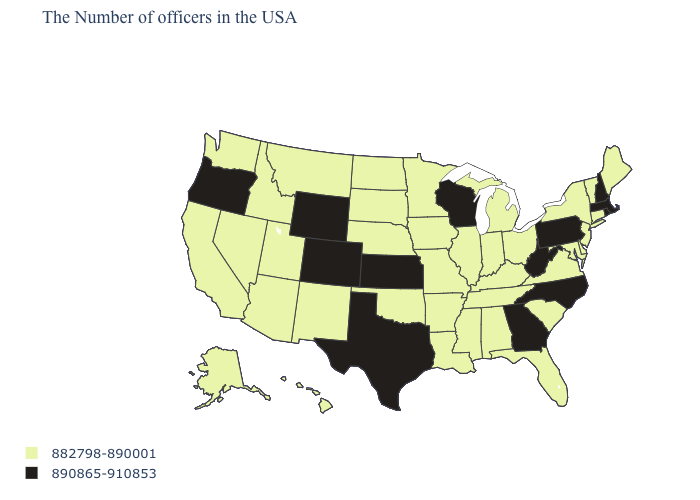Name the states that have a value in the range 890865-910853?
Answer briefly. Massachusetts, Rhode Island, New Hampshire, Pennsylvania, North Carolina, West Virginia, Georgia, Wisconsin, Kansas, Texas, Wyoming, Colorado, Oregon. What is the highest value in the USA?
Be succinct. 890865-910853. Does the map have missing data?
Write a very short answer. No. Does the map have missing data?
Answer briefly. No. What is the value of New Hampshire?
Short answer required. 890865-910853. Which states hav the highest value in the South?
Quick response, please. North Carolina, West Virginia, Georgia, Texas. What is the lowest value in the USA?
Quick response, please. 882798-890001. Which states have the highest value in the USA?
Give a very brief answer. Massachusetts, Rhode Island, New Hampshire, Pennsylvania, North Carolina, West Virginia, Georgia, Wisconsin, Kansas, Texas, Wyoming, Colorado, Oregon. Does Colorado have a higher value than Maine?
Be succinct. Yes. What is the value of Indiana?
Concise answer only. 882798-890001. Does the first symbol in the legend represent the smallest category?
Give a very brief answer. Yes. Among the states that border California , does Arizona have the highest value?
Answer briefly. No. Among the states that border Connecticut , does Massachusetts have the highest value?
Keep it brief. Yes. What is the value of South Dakota?
Answer briefly. 882798-890001. 